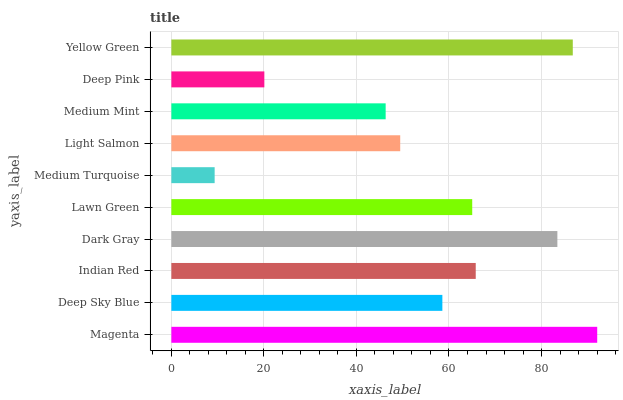Is Medium Turquoise the minimum?
Answer yes or no. Yes. Is Magenta the maximum?
Answer yes or no. Yes. Is Deep Sky Blue the minimum?
Answer yes or no. No. Is Deep Sky Blue the maximum?
Answer yes or no. No. Is Magenta greater than Deep Sky Blue?
Answer yes or no. Yes. Is Deep Sky Blue less than Magenta?
Answer yes or no. Yes. Is Deep Sky Blue greater than Magenta?
Answer yes or no. No. Is Magenta less than Deep Sky Blue?
Answer yes or no. No. Is Lawn Green the high median?
Answer yes or no. Yes. Is Deep Sky Blue the low median?
Answer yes or no. Yes. Is Deep Sky Blue the high median?
Answer yes or no. No. Is Medium Turquoise the low median?
Answer yes or no. No. 